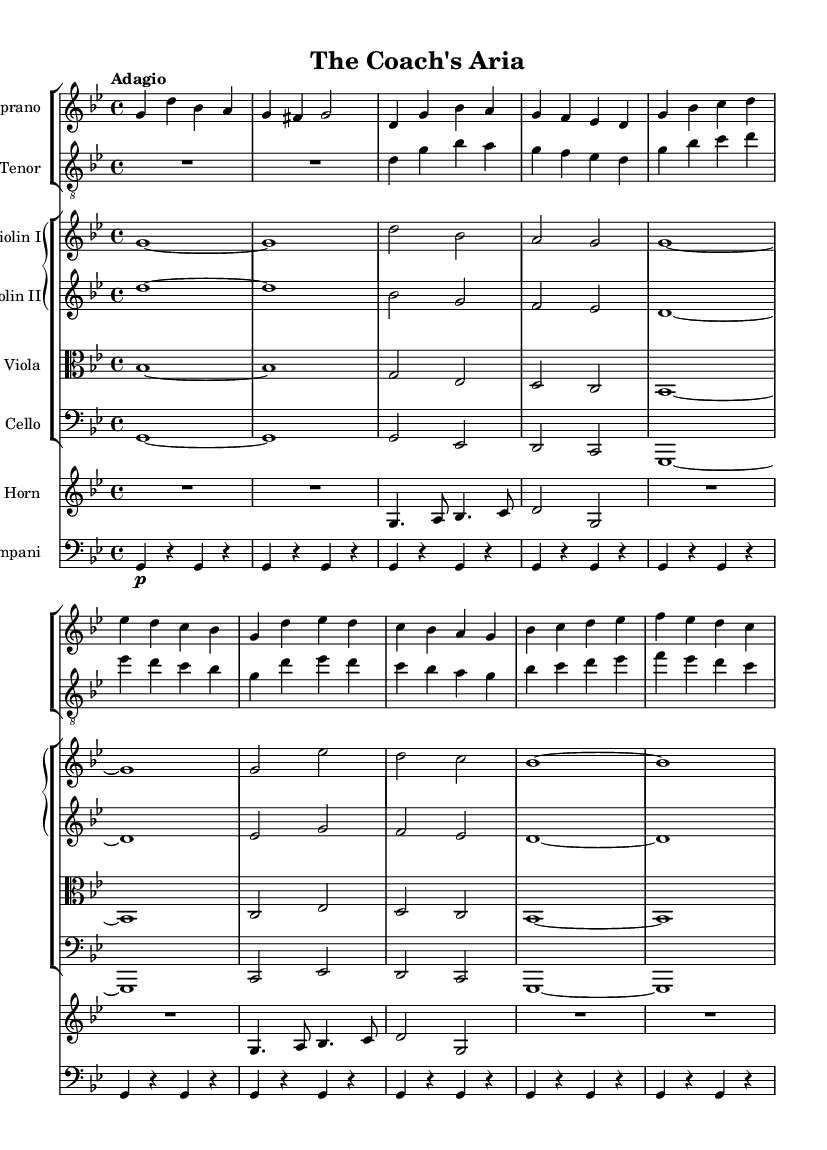What is the key signature of this music? The key signature is G minor, which has two flats. This can be determined from the key signature indicated at the beginning of the staff, showing the flats on the B and E lines.
Answer: G minor What is the time signature of this music? The time signature is 4/4, which indicates four beats in each measure and a quarter note gets one beat. This is represented in the music by the notation at the beginning, shown as "4/4."
Answer: 4/4 What is the tempo marking of this piece? The tempo marking is "Adagio," which indicates a slow pace. This is stated at the beginning of the music just after the time signature.
Answer: Adagio How many vocal parts are present in the score? There are two vocal parts, indicated by the presence of Soprano and Tenor staffs in the score. Each vocal part is separately notated under its corresponding staff, making it clear that two voices are intended.
Answer: Two Which instruments are included in the orchestration? The orchestration includes Violin I, Violin II, Viola, Cello, French Horn, and Timpani, as indicated in their respective staff groups. Each instrument is labeled at the start of its staff.
Answer: Violin I, Violin II, Viola, Cello, French Horn, Timpani What themes are reflected in the lyrics sung by the soprano? The themes in the lyrics reflect leadership and character building, emphasized by phrases discussing standing tall, character being greater than victory, and the importance of the journey over triumph. This is analyzed by looking closely at the lyrics provided for the soprano part.
Answer: Leadership and character building What type of musical form or structure does this aria represent? This aria represents a song form typically found in opera, focusing on emotional expression through vocal solo and orchestral accompaniment. This is deduced from the organization of parts and the presence of lyrics meant for solo performance.
Answer: Aria 